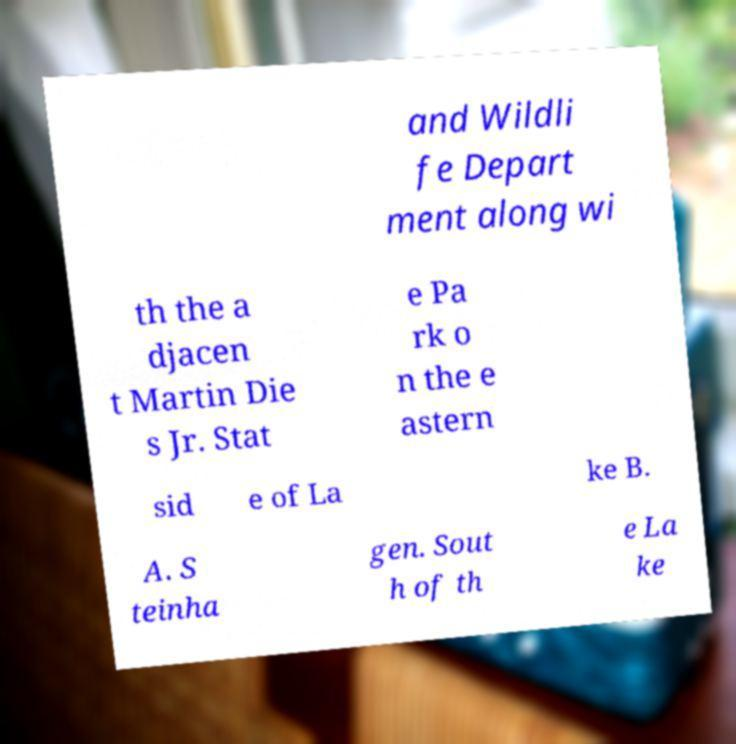Please read and relay the text visible in this image. What does it say? and Wildli fe Depart ment along wi th the a djacen t Martin Die s Jr. Stat e Pa rk o n the e astern sid e of La ke B. A. S teinha gen. Sout h of th e La ke 